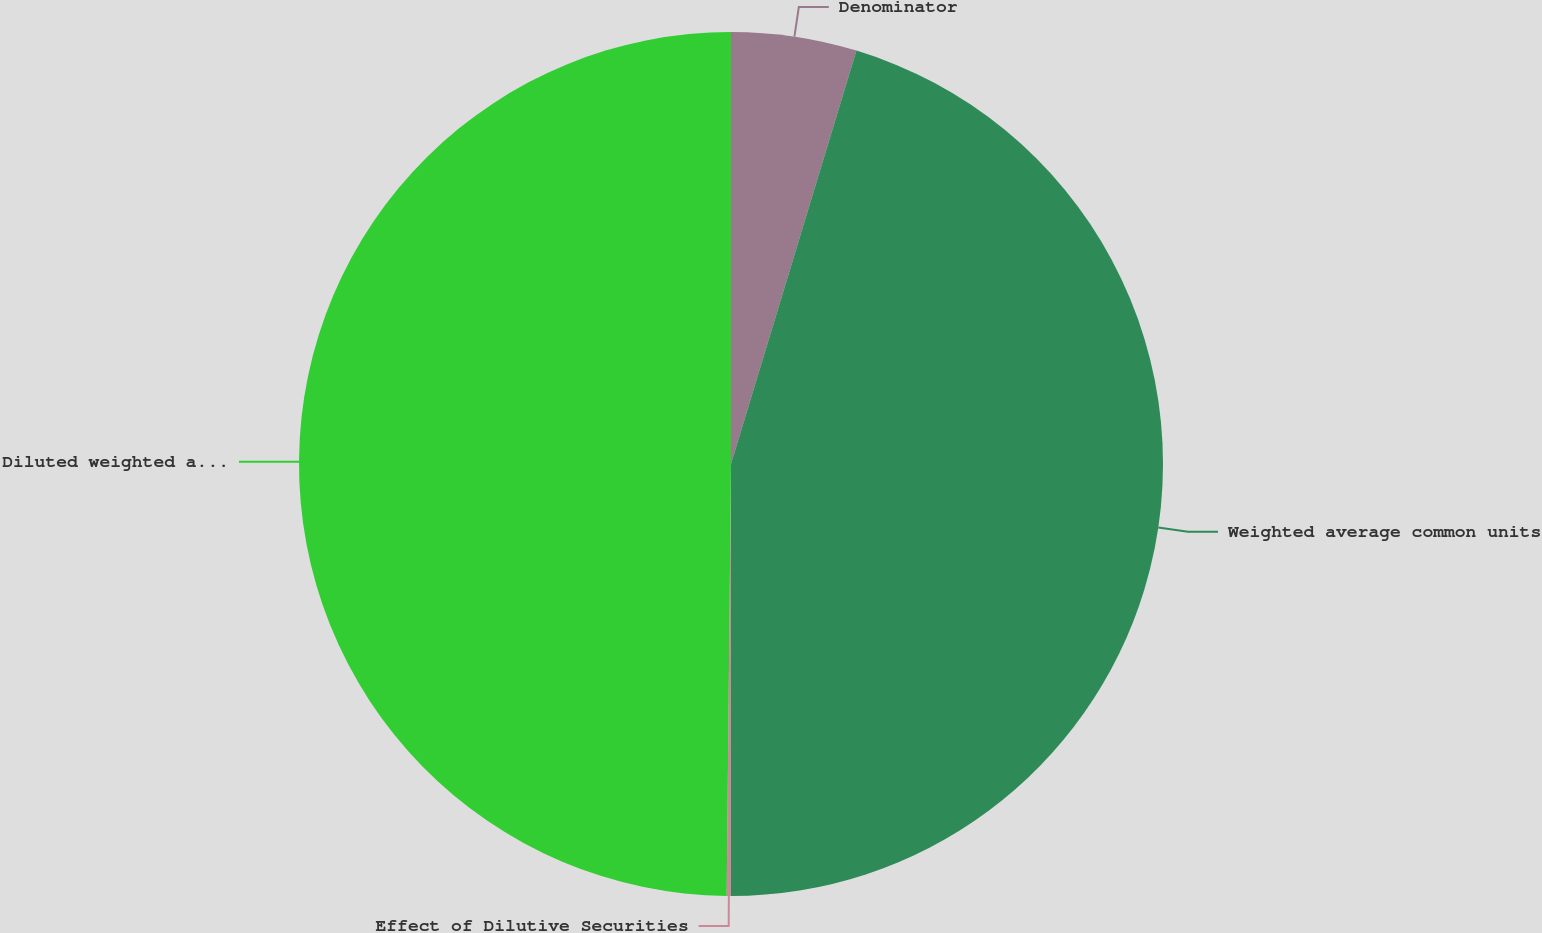Convert chart. <chart><loc_0><loc_0><loc_500><loc_500><pie_chart><fcel>Denominator<fcel>Weighted average common units<fcel>Effect of Dilutive Securities<fcel>Diluted weighted average<nl><fcel>4.69%<fcel>45.31%<fcel>0.16%<fcel>49.84%<nl></chart> 